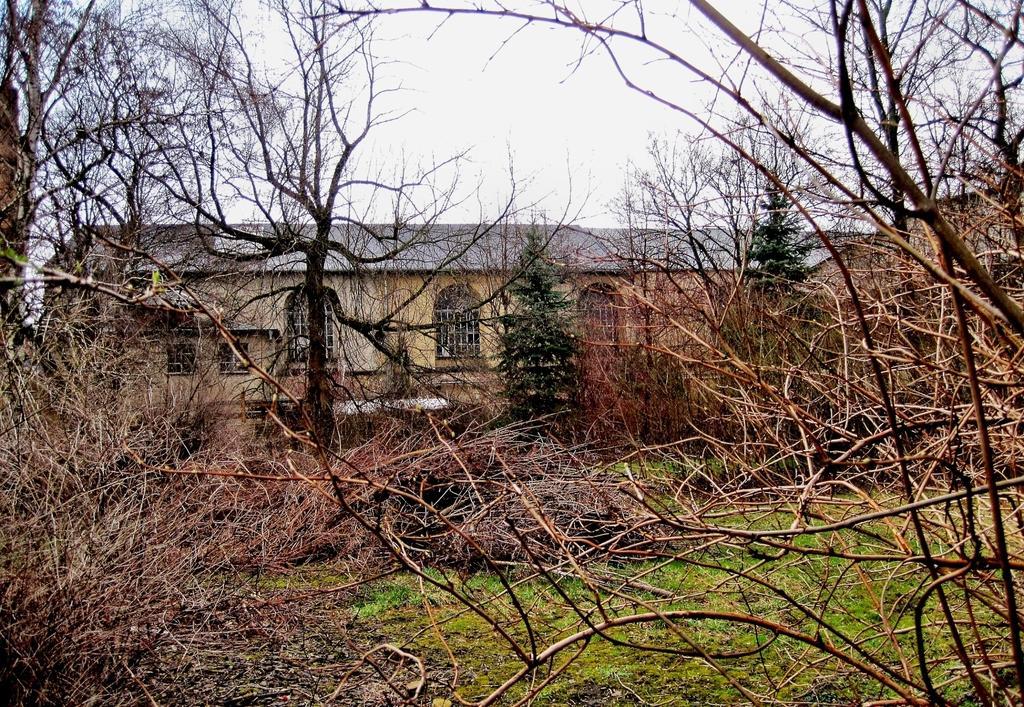Could you give a brief overview of what you see in this image? In the image we can see some trees and grass. Behind the trees there is a building. Top of the image there are some clouds and sky. 